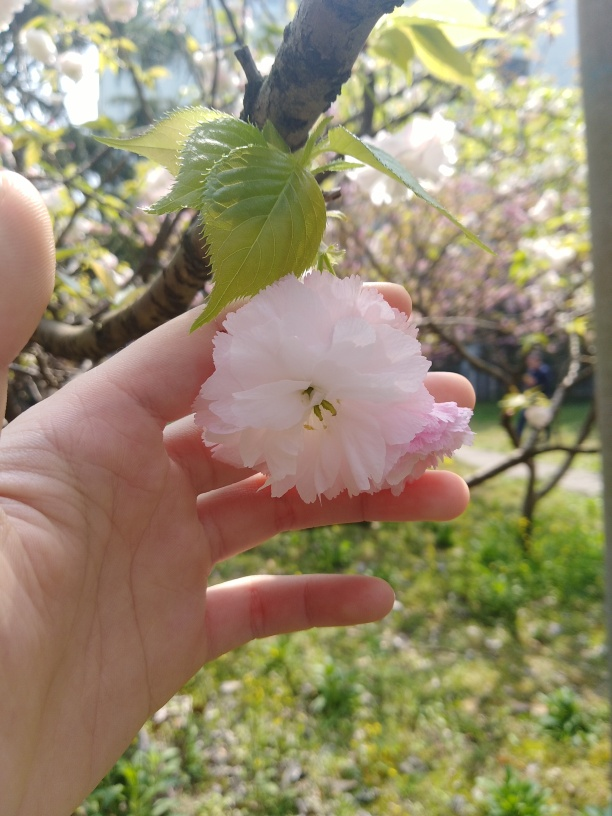Is the exposure spot on? The exposure in the image is well-balanced, providing a clear view of the delicate pink cherry blossom against a softly blurred background. The lighting is gentle and diffused, allowing the intricate details and subtle color variations of the petals to be seen without any areas of harsh shadow or overexposure, contributing to a visually pleasing composition. 